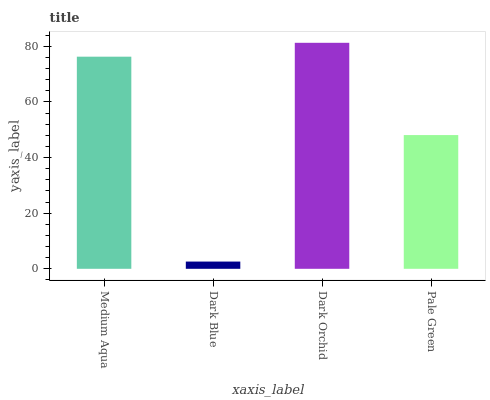Is Dark Orchid the minimum?
Answer yes or no. No. Is Dark Blue the maximum?
Answer yes or no. No. Is Dark Orchid greater than Dark Blue?
Answer yes or no. Yes. Is Dark Blue less than Dark Orchid?
Answer yes or no. Yes. Is Dark Blue greater than Dark Orchid?
Answer yes or no. No. Is Dark Orchid less than Dark Blue?
Answer yes or no. No. Is Medium Aqua the high median?
Answer yes or no. Yes. Is Pale Green the low median?
Answer yes or no. Yes. Is Dark Blue the high median?
Answer yes or no. No. Is Dark Orchid the low median?
Answer yes or no. No. 